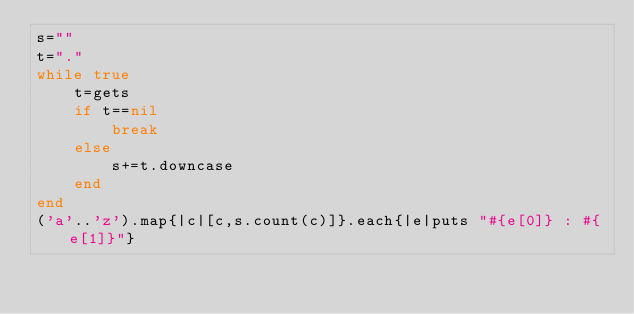Convert code to text. <code><loc_0><loc_0><loc_500><loc_500><_Ruby_>s=""
t="."
while true
    t=gets
    if t==nil
        break
    else
        s+=t.downcase
    end
end
('a'..'z').map{|c|[c,s.count(c)]}.each{|e|puts "#{e[0]} : #{e[1]}"}
</code> 